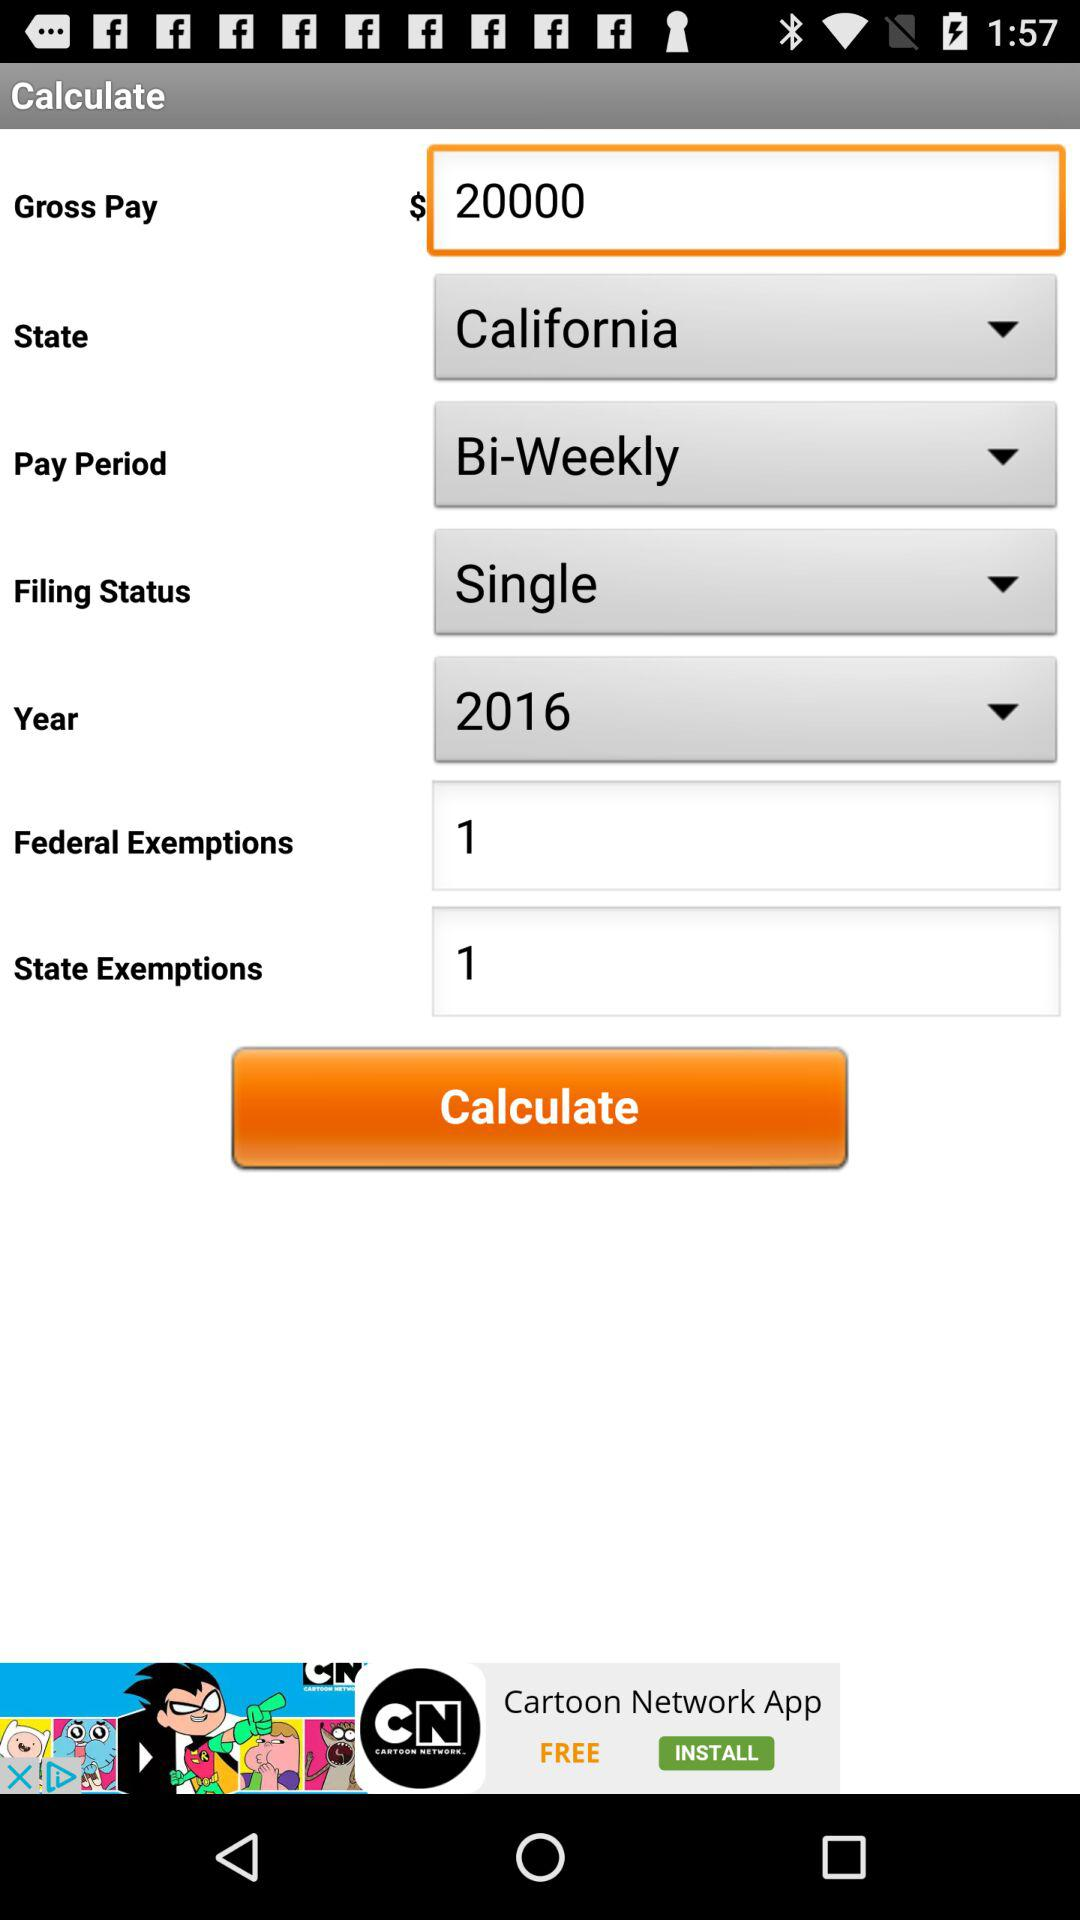Which "Pay Period" is selected? The selected pay period is "Bi-Weekly". 